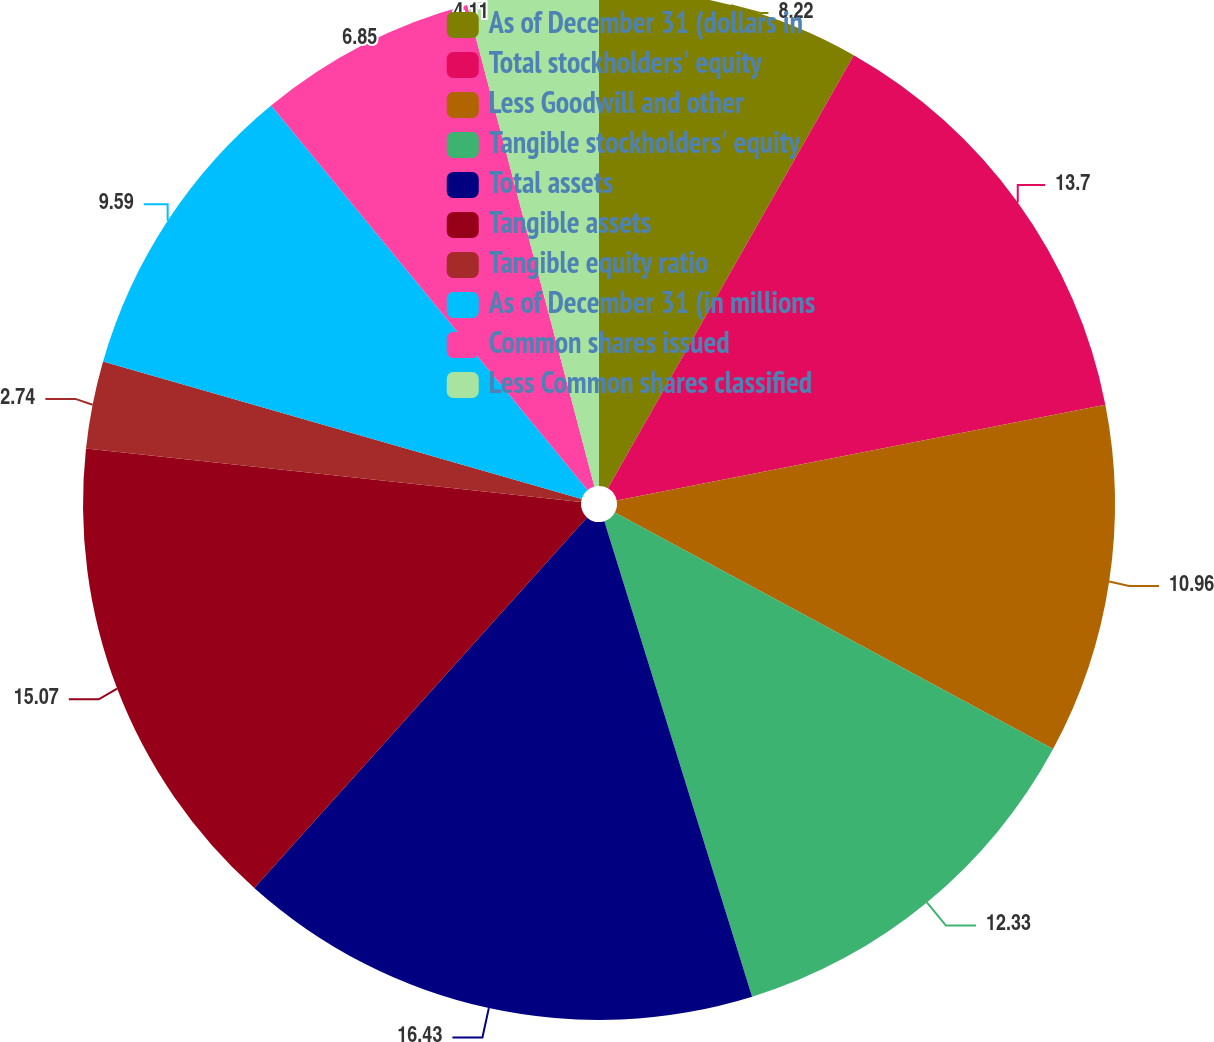<chart> <loc_0><loc_0><loc_500><loc_500><pie_chart><fcel>As of December 31 (dollars in<fcel>Total stockholders' equity<fcel>Less Goodwill and other<fcel>Tangible stockholders' equity<fcel>Total assets<fcel>Tangible assets<fcel>Tangible equity ratio<fcel>As of December 31 (in millions<fcel>Common shares issued<fcel>Less Common shares classified<nl><fcel>8.22%<fcel>13.7%<fcel>10.96%<fcel>12.33%<fcel>16.44%<fcel>15.07%<fcel>2.74%<fcel>9.59%<fcel>6.85%<fcel>4.11%<nl></chart> 